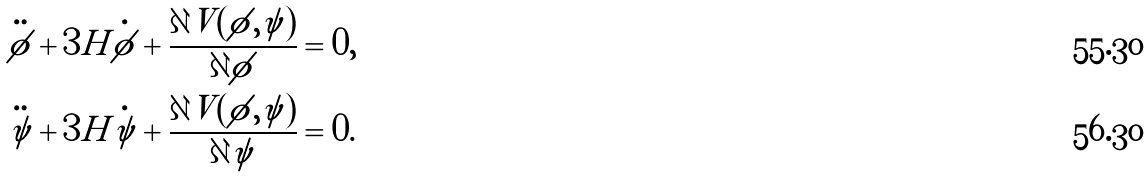Convert formula to latex. <formula><loc_0><loc_0><loc_500><loc_500>& \ddot { \phi } + 3 H \dot { \phi } + \frac { \partial V ( \phi , \psi ) } { \partial \phi } = 0 , \\ & \ddot { \psi } + 3 H \dot { \psi } + \frac { \partial V ( \phi , \psi ) } { \partial \psi } = 0 .</formula> 